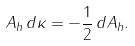Convert formula to latex. <formula><loc_0><loc_0><loc_500><loc_500>A _ { h } \, d \kappa = - \frac { 1 } { 2 } \, d A _ { h } .</formula> 